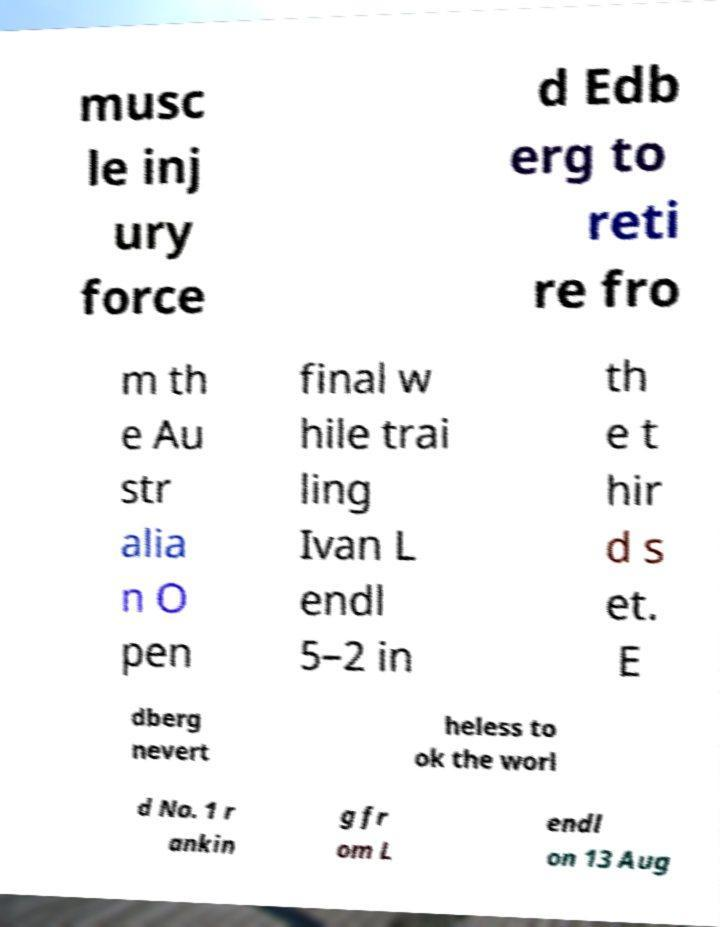There's text embedded in this image that I need extracted. Can you transcribe it verbatim? musc le inj ury force d Edb erg to reti re fro m th e Au str alia n O pen final w hile trai ling Ivan L endl 5–2 in th e t hir d s et. E dberg nevert heless to ok the worl d No. 1 r ankin g fr om L endl on 13 Aug 